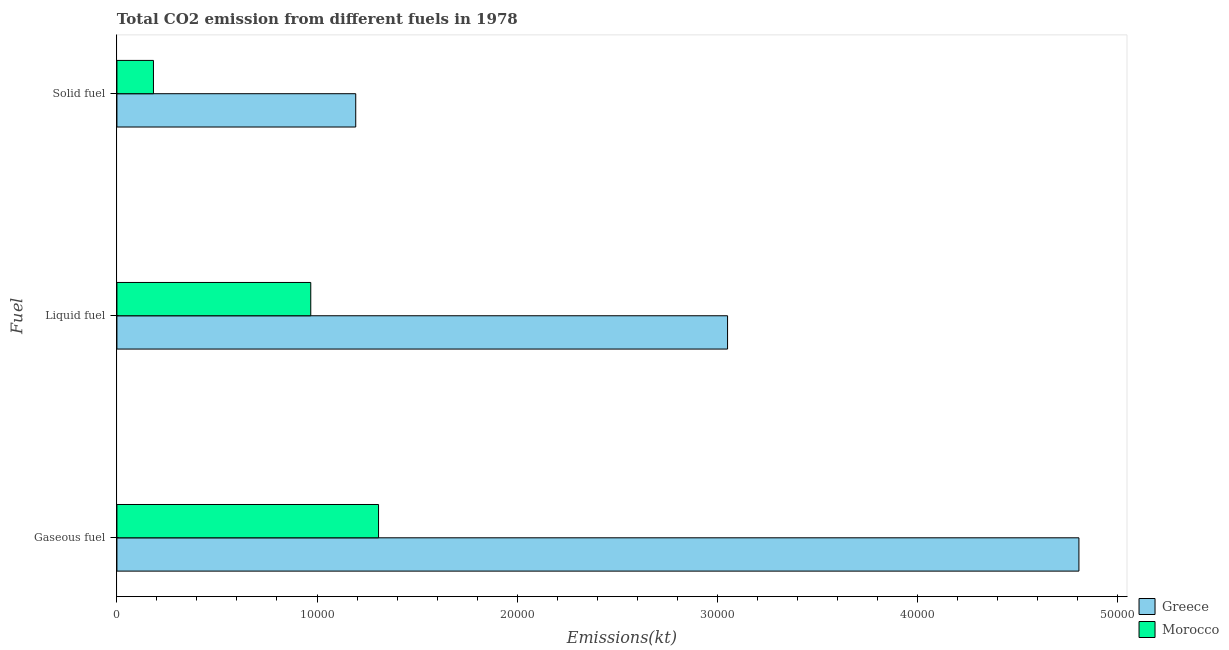Are the number of bars on each tick of the Y-axis equal?
Keep it short and to the point. Yes. What is the label of the 1st group of bars from the top?
Ensure brevity in your answer.  Solid fuel. What is the amount of co2 emissions from liquid fuel in Greece?
Provide a succinct answer. 3.05e+04. Across all countries, what is the maximum amount of co2 emissions from liquid fuel?
Ensure brevity in your answer.  3.05e+04. Across all countries, what is the minimum amount of co2 emissions from gaseous fuel?
Your answer should be compact. 1.31e+04. In which country was the amount of co2 emissions from gaseous fuel minimum?
Make the answer very short. Morocco. What is the total amount of co2 emissions from liquid fuel in the graph?
Provide a short and direct response. 4.02e+04. What is the difference between the amount of co2 emissions from gaseous fuel in Morocco and that in Greece?
Keep it short and to the point. -3.50e+04. What is the difference between the amount of co2 emissions from liquid fuel in Greece and the amount of co2 emissions from gaseous fuel in Morocco?
Offer a very short reply. 1.74e+04. What is the average amount of co2 emissions from gaseous fuel per country?
Offer a very short reply. 3.06e+04. What is the difference between the amount of co2 emissions from gaseous fuel and amount of co2 emissions from liquid fuel in Morocco?
Make the answer very short. 3388.31. What is the ratio of the amount of co2 emissions from solid fuel in Greece to that in Morocco?
Make the answer very short. 6.54. What is the difference between the highest and the second highest amount of co2 emissions from liquid fuel?
Your answer should be compact. 2.08e+04. What is the difference between the highest and the lowest amount of co2 emissions from liquid fuel?
Ensure brevity in your answer.  2.08e+04. Is the sum of the amount of co2 emissions from gaseous fuel in Morocco and Greece greater than the maximum amount of co2 emissions from liquid fuel across all countries?
Provide a short and direct response. Yes. What does the 2nd bar from the bottom in Gaseous fuel represents?
Your response must be concise. Morocco. How many bars are there?
Offer a very short reply. 6. Are all the bars in the graph horizontal?
Your answer should be very brief. Yes. How many countries are there in the graph?
Your answer should be compact. 2. Does the graph contain grids?
Your response must be concise. No. How many legend labels are there?
Your answer should be compact. 2. What is the title of the graph?
Make the answer very short. Total CO2 emission from different fuels in 1978. What is the label or title of the X-axis?
Keep it short and to the point. Emissions(kt). What is the label or title of the Y-axis?
Offer a very short reply. Fuel. What is the Emissions(kt) of Greece in Gaseous fuel?
Offer a very short reply. 4.81e+04. What is the Emissions(kt) in Morocco in Gaseous fuel?
Your response must be concise. 1.31e+04. What is the Emissions(kt) in Greece in Liquid fuel?
Keep it short and to the point. 3.05e+04. What is the Emissions(kt) of Morocco in Liquid fuel?
Offer a very short reply. 9688.21. What is the Emissions(kt) in Greece in Solid fuel?
Provide a short and direct response. 1.19e+04. What is the Emissions(kt) in Morocco in Solid fuel?
Make the answer very short. 1826.17. Across all Fuel, what is the maximum Emissions(kt) of Greece?
Ensure brevity in your answer.  4.81e+04. Across all Fuel, what is the maximum Emissions(kt) of Morocco?
Ensure brevity in your answer.  1.31e+04. Across all Fuel, what is the minimum Emissions(kt) in Greece?
Provide a short and direct response. 1.19e+04. Across all Fuel, what is the minimum Emissions(kt) in Morocco?
Offer a terse response. 1826.17. What is the total Emissions(kt) of Greece in the graph?
Your response must be concise. 9.05e+04. What is the total Emissions(kt) of Morocco in the graph?
Ensure brevity in your answer.  2.46e+04. What is the difference between the Emissions(kt) of Greece in Gaseous fuel and that in Liquid fuel?
Your answer should be very brief. 1.76e+04. What is the difference between the Emissions(kt) of Morocco in Gaseous fuel and that in Liquid fuel?
Your response must be concise. 3388.31. What is the difference between the Emissions(kt) in Greece in Gaseous fuel and that in Solid fuel?
Offer a terse response. 3.61e+04. What is the difference between the Emissions(kt) in Morocco in Gaseous fuel and that in Solid fuel?
Your answer should be very brief. 1.13e+04. What is the difference between the Emissions(kt) of Greece in Liquid fuel and that in Solid fuel?
Offer a terse response. 1.86e+04. What is the difference between the Emissions(kt) of Morocco in Liquid fuel and that in Solid fuel?
Your answer should be very brief. 7862.05. What is the difference between the Emissions(kt) in Greece in Gaseous fuel and the Emissions(kt) in Morocco in Liquid fuel?
Offer a very short reply. 3.84e+04. What is the difference between the Emissions(kt) in Greece in Gaseous fuel and the Emissions(kt) in Morocco in Solid fuel?
Your response must be concise. 4.63e+04. What is the difference between the Emissions(kt) in Greece in Liquid fuel and the Emissions(kt) in Morocco in Solid fuel?
Keep it short and to the point. 2.87e+04. What is the average Emissions(kt) in Greece per Fuel?
Offer a very short reply. 3.02e+04. What is the average Emissions(kt) in Morocco per Fuel?
Provide a succinct answer. 8196.97. What is the difference between the Emissions(kt) of Greece and Emissions(kt) of Morocco in Gaseous fuel?
Make the answer very short. 3.50e+04. What is the difference between the Emissions(kt) in Greece and Emissions(kt) in Morocco in Liquid fuel?
Make the answer very short. 2.08e+04. What is the difference between the Emissions(kt) in Greece and Emissions(kt) in Morocco in Solid fuel?
Give a very brief answer. 1.01e+04. What is the ratio of the Emissions(kt) of Greece in Gaseous fuel to that in Liquid fuel?
Provide a succinct answer. 1.58. What is the ratio of the Emissions(kt) of Morocco in Gaseous fuel to that in Liquid fuel?
Your answer should be very brief. 1.35. What is the ratio of the Emissions(kt) in Greece in Gaseous fuel to that in Solid fuel?
Your response must be concise. 4.03. What is the ratio of the Emissions(kt) in Morocco in Gaseous fuel to that in Solid fuel?
Provide a short and direct response. 7.16. What is the ratio of the Emissions(kt) in Greece in Liquid fuel to that in Solid fuel?
Make the answer very short. 2.56. What is the ratio of the Emissions(kt) of Morocco in Liquid fuel to that in Solid fuel?
Your answer should be compact. 5.31. What is the difference between the highest and the second highest Emissions(kt) in Greece?
Keep it short and to the point. 1.76e+04. What is the difference between the highest and the second highest Emissions(kt) in Morocco?
Make the answer very short. 3388.31. What is the difference between the highest and the lowest Emissions(kt) of Greece?
Provide a succinct answer. 3.61e+04. What is the difference between the highest and the lowest Emissions(kt) in Morocco?
Your answer should be very brief. 1.13e+04. 